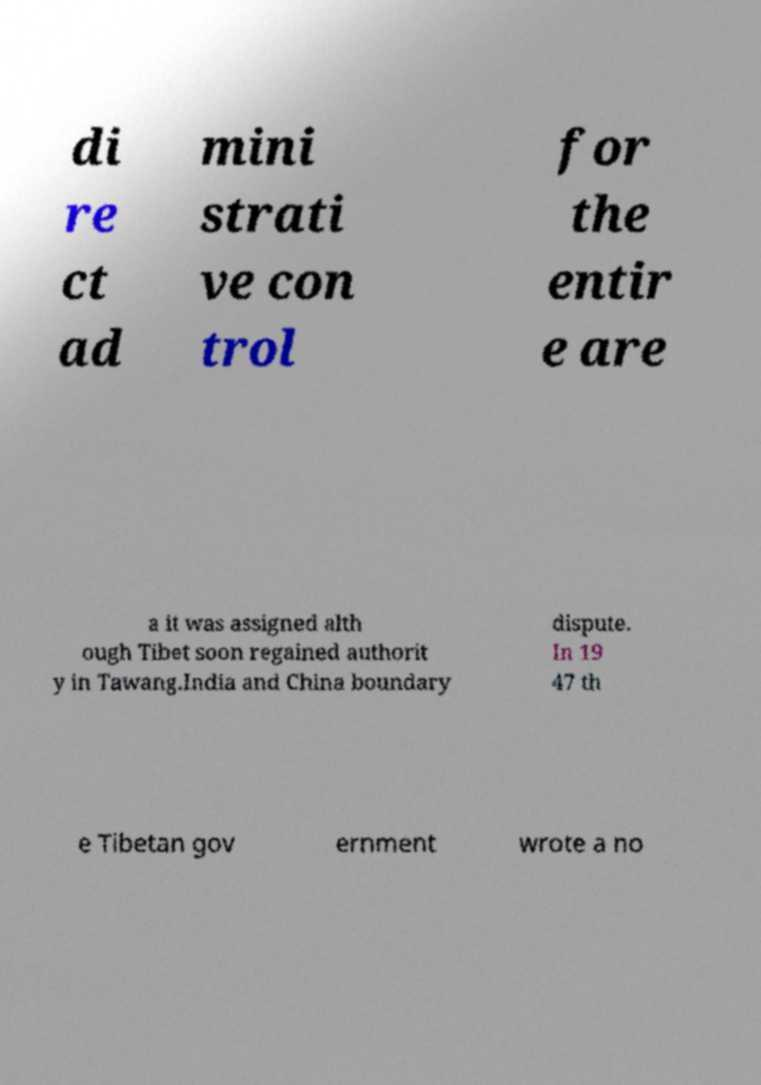Can you accurately transcribe the text from the provided image for me? di re ct ad mini strati ve con trol for the entir e are a it was assigned alth ough Tibet soon regained authorit y in Tawang.India and China boundary dispute. In 19 47 th e Tibetan gov ernment wrote a no 